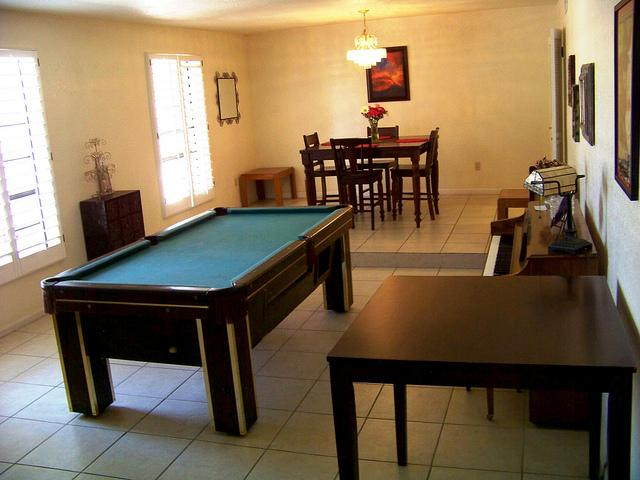What kind of room is this one? Please explain your reasoning. recreation room. It has a pool table and piano for some fun 